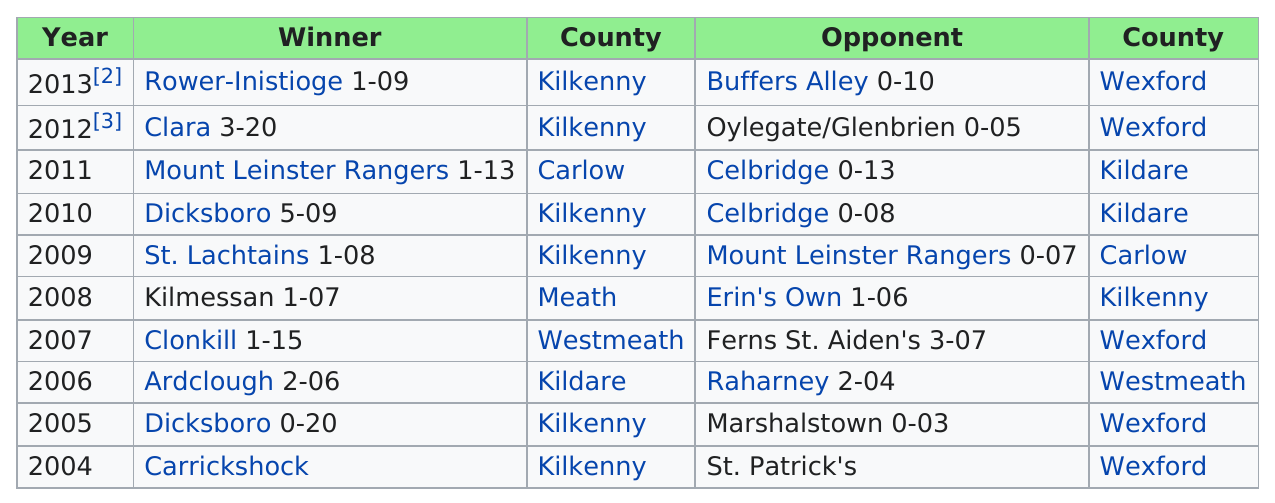Give some essential details in this illustration. Carrickshock was the first winner in 2004. The Kilmessan team won the championship after Clonkill in 2007. Kilkenny county has the most amount of winners. There are 10 winners in total. I declare that Carlow is the only county to have a single winner. 